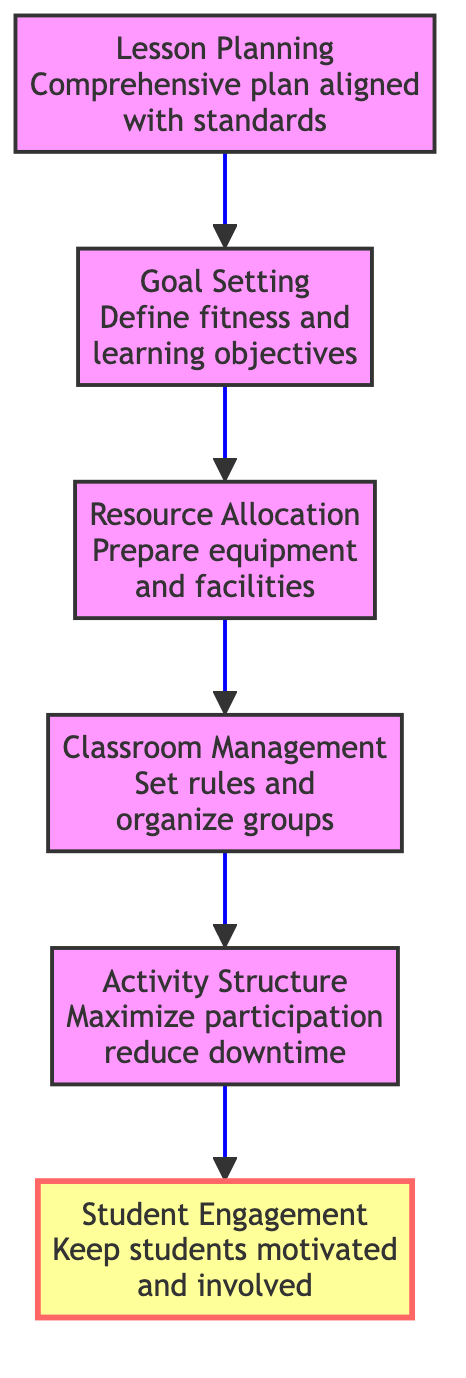What is the top node in the diagram? The top node in the diagram is labeled "Student Engagement." Since the diagram is structured in a bottom-to-top flow, the topmost element after following the arrows is "Student Engagement."
Answer: Student Engagement How many total nodes are in the diagram? The diagram contains six nodes, which include "Lesson Planning," "Goal Setting," "Resource Allocation," "Classroom Management," "Activity Structure," and "Student Engagement." This can be counted directly from the listed elements.
Answer: Six What does "Activity Structure" aim to maximize? "Activity Structure" aims to maximize "participation." By focusing on organizing activities to enhance engagement, this node emphasizes increasing student involvement during PE classes.
Answer: Participation In which order does "Resource Allocation" come in the flow? "Resource Allocation" comes immediately after "Goal Setting" in the flow. Following the bottom-to-top structure, it can be confirmed by following the arrows starting from "Goal Setting."
Answer: After Goal Setting Which node directly precedes "Student Engagement"? The node that directly precedes "Student Engagement" is "Activity Structure." The flow connects sequentially leading up to "Student Engagement," confirming this relationship.
Answer: Activity Structure What is the primary focus of "Classroom Management"? The primary focus of "Classroom Management" is to "set rules and organize groups." This description highlights the efforts required to maintain an effective and organized learning environment in PE classes.
Answer: Set rules and organize groups How does "Lesson Planning" contribute to the overall time management process? "Lesson Planning" sets the foundation for effective time management by creating a comprehensive plan that aligns with standards and student needs, which influences all subsequent nodes.
Answer: Comprehensive plan Which node is essential for preparing equipment and facilities? "Resource Allocation" is essential for preparing equipment and facilities as it ensures all necessary resources are available before the class begins, supporting a smooth transition to activities.
Answer: Resource Allocation 